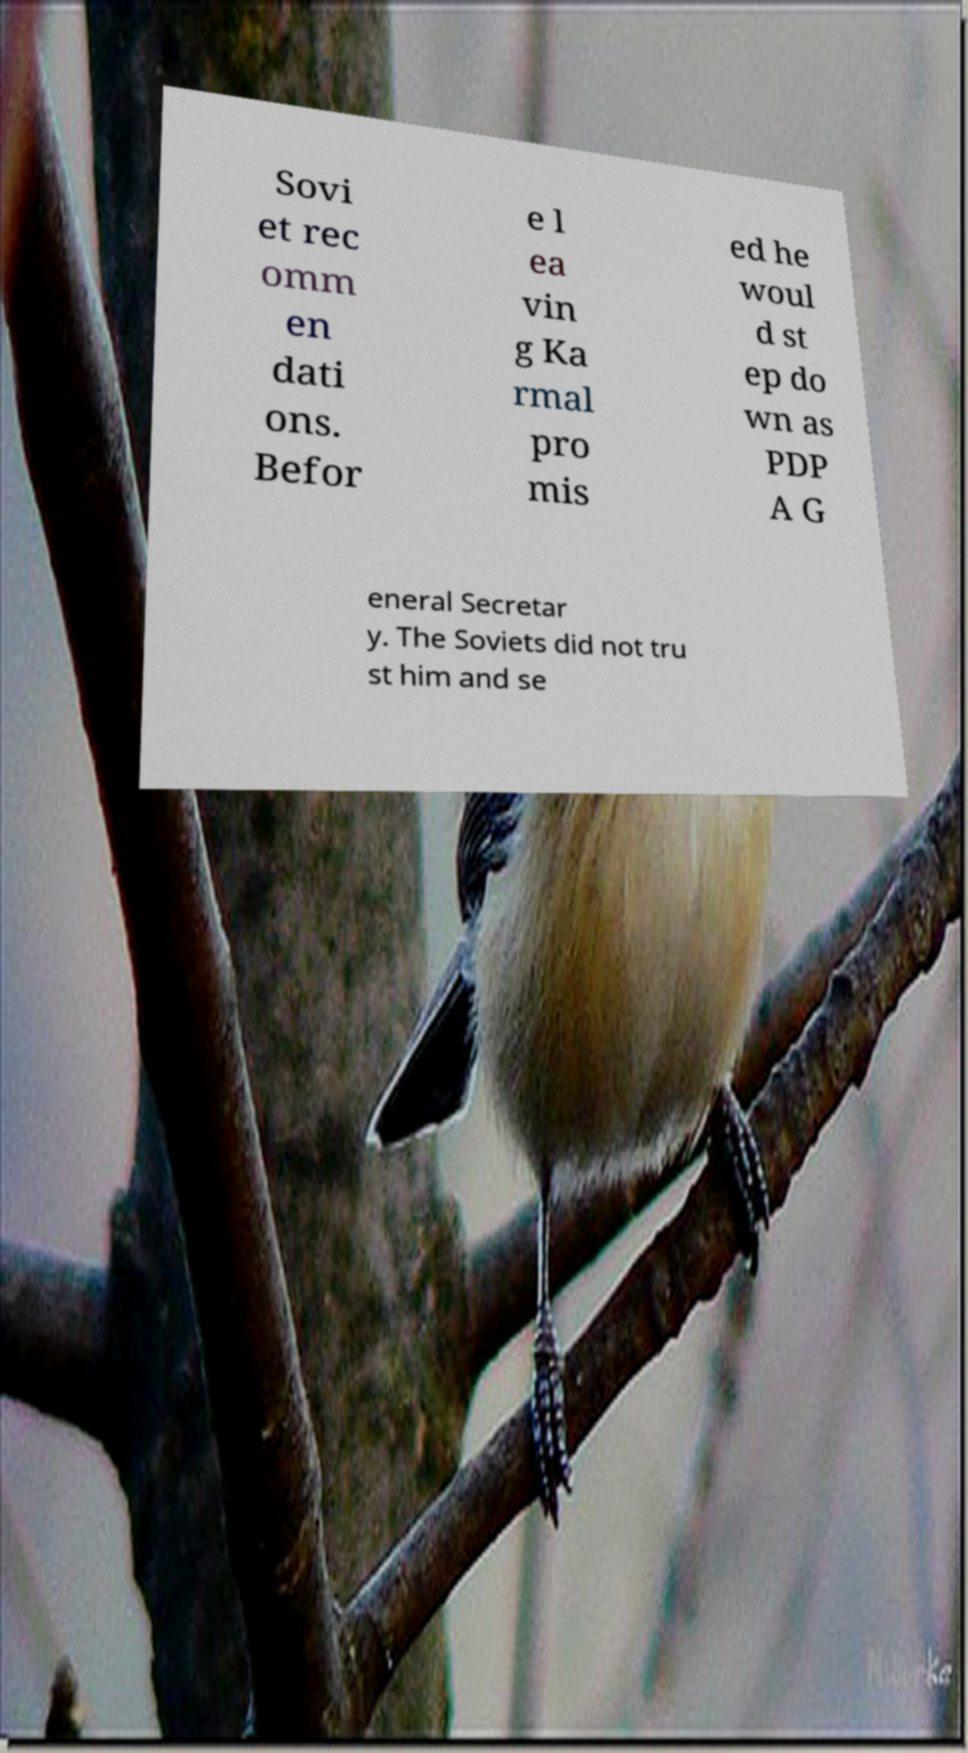There's text embedded in this image that I need extracted. Can you transcribe it verbatim? Sovi et rec omm en dati ons. Befor e l ea vin g Ka rmal pro mis ed he woul d st ep do wn as PDP A G eneral Secretar y. The Soviets did not tru st him and se 